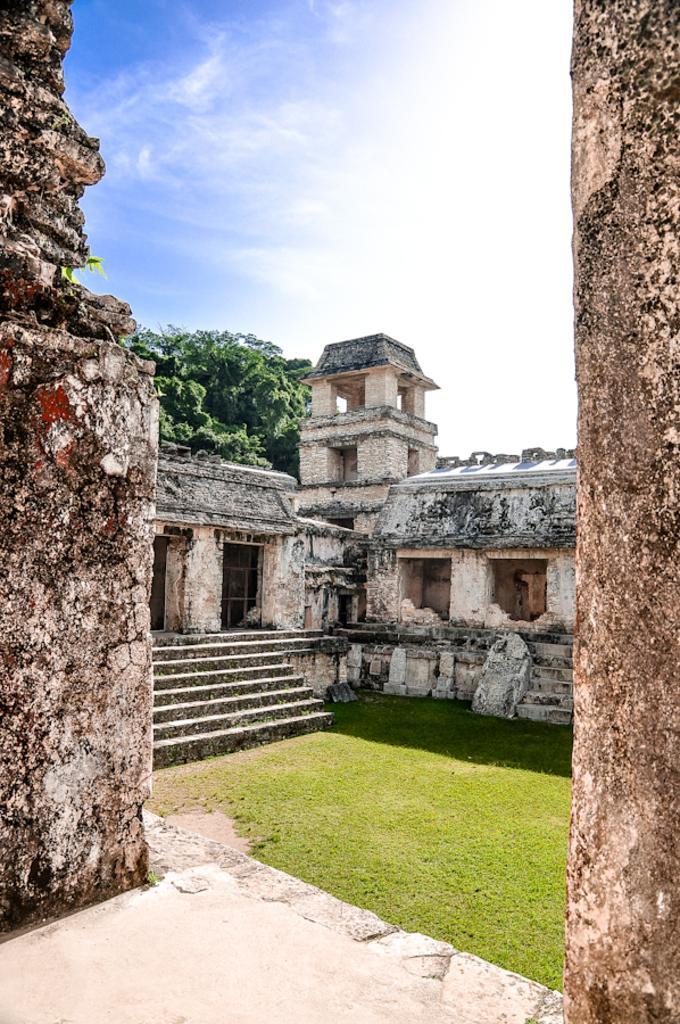How would you summarize this image in a sentence or two? In this image we can see there is a building with stairs and there is a grass. At the back there is a tree. And at the top there is a sky. 